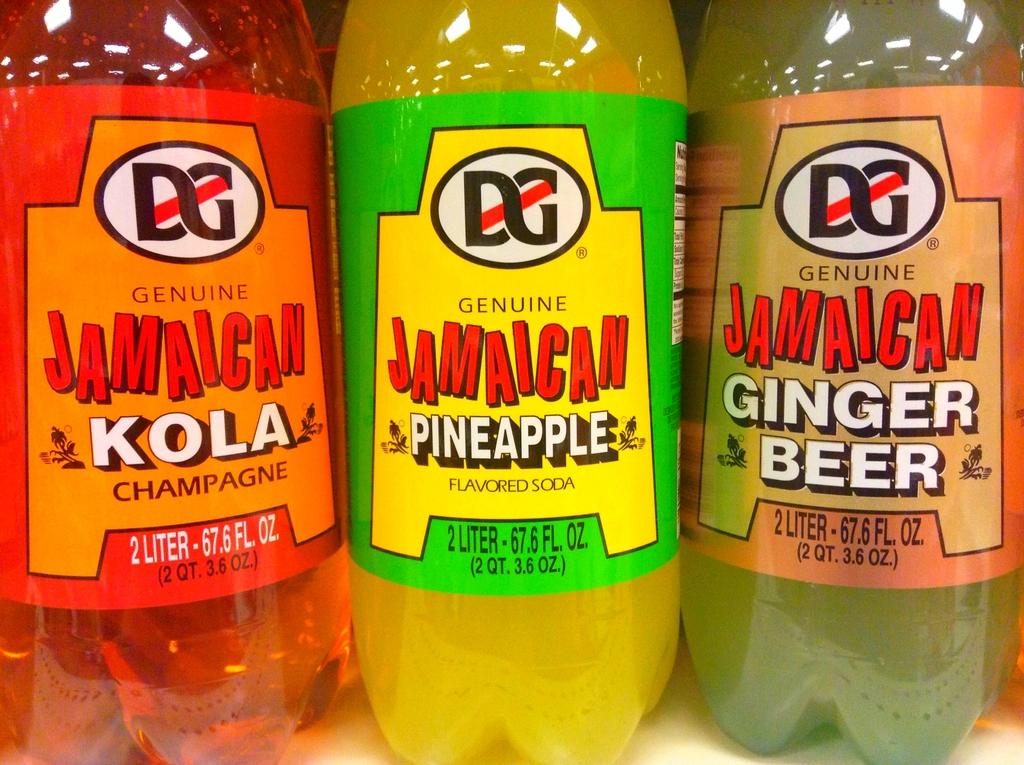<image>
Write a terse but informative summary of the picture. Three different colored Jamaican Kolas placed next to one another. 